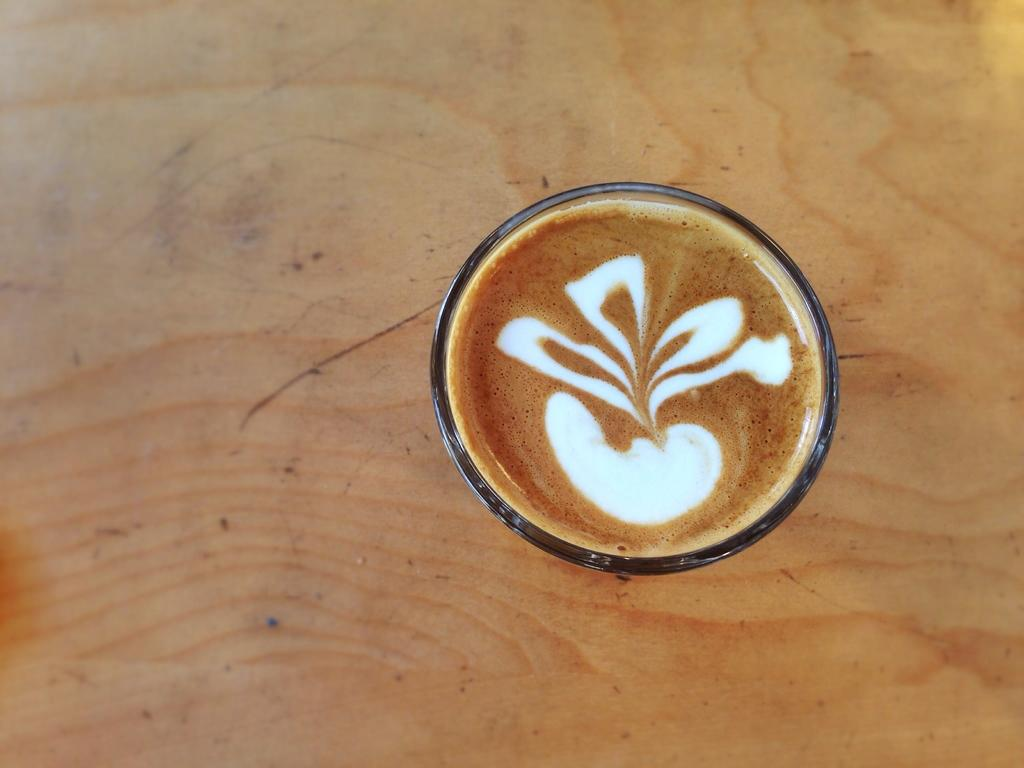What piece of furniture is present in the image? There is a table in the image. What object is placed on the table? There is a cup on the table. What is inside the cup? The cup contains coffee. What decorative element is present in the coffee? There is coffee art in the cup. What type of belief is represented by the coffee art in the image? There is no indication of any beliefs in the image; it simply features a cup of coffee with coffee art. 